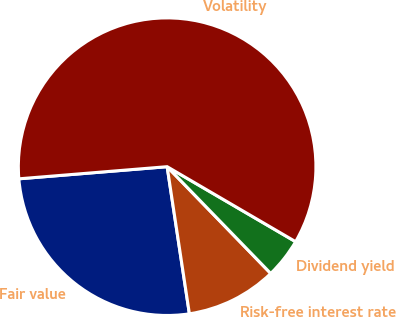Convert chart. <chart><loc_0><loc_0><loc_500><loc_500><pie_chart><fcel>Fair value<fcel>Risk-free interest rate<fcel>Dividend yield<fcel>Volatility<nl><fcel>26.09%<fcel>9.87%<fcel>4.33%<fcel>59.71%<nl></chart> 